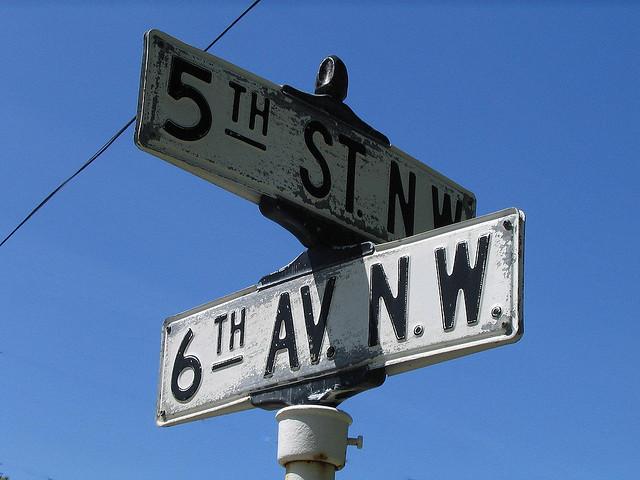Is it a clear day?
Short answer required. Yes. What is that number on top of the sign?
Concise answer only. 5. Is this 5th st. and 6th Ave?
Quick response, please. Yes. Is there a wire in the picture?
Quick response, please. Yes. 